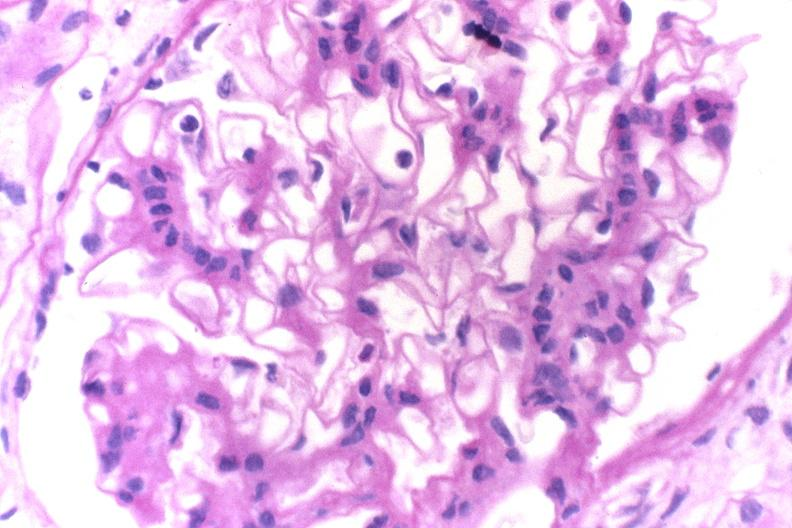what does this image show?
Answer the question using a single word or phrase. Glomerulonephritis 